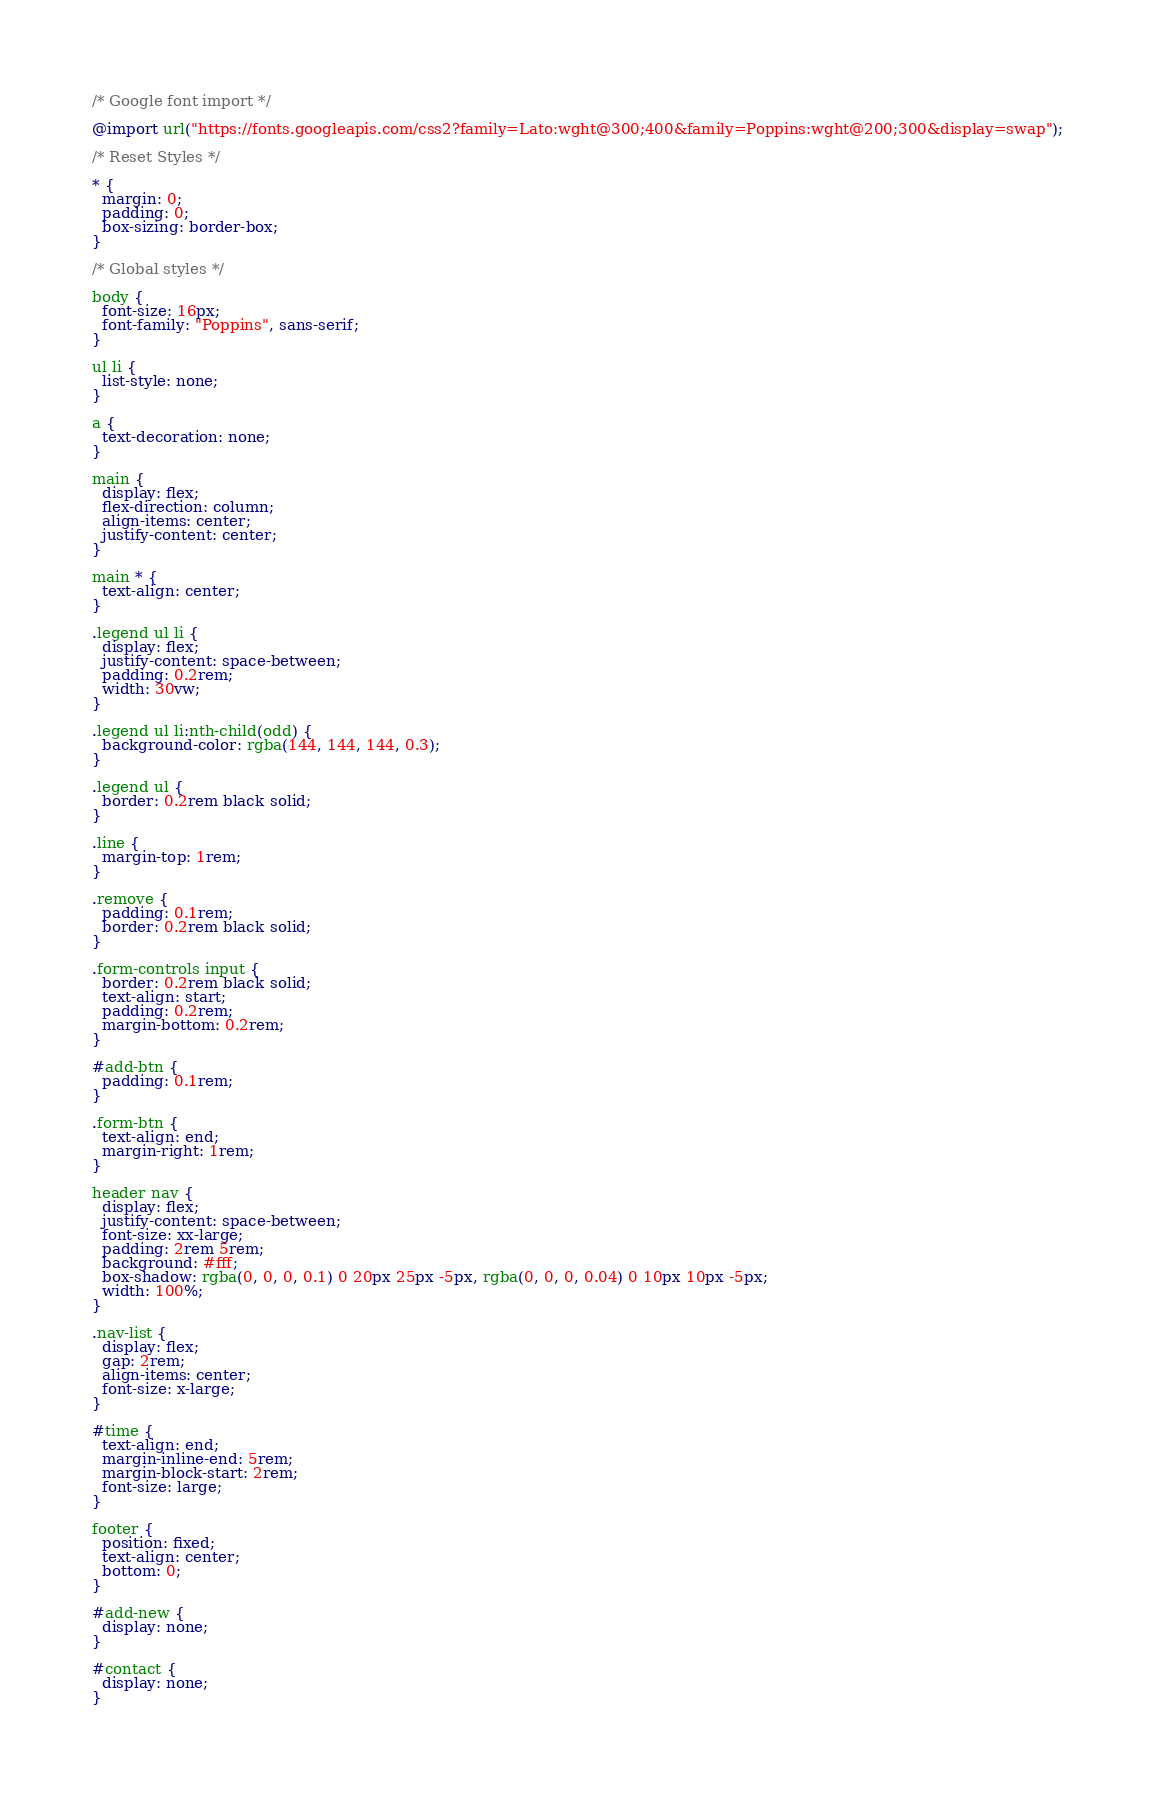<code> <loc_0><loc_0><loc_500><loc_500><_CSS_>/* Google font import */

@import url("https://fonts.googleapis.com/css2?family=Lato:wght@300;400&family=Poppins:wght@200;300&display=swap");

/* Reset Styles */

* {
  margin: 0;
  padding: 0;
  box-sizing: border-box;
}

/* Global styles */

body {
  font-size: 16px;
  font-family: "Poppins", sans-serif;
}

ul li {
  list-style: none;
}

a {
  text-decoration: none;
}

main {
  display: flex;
  flex-direction: column;
  align-items: center;
  justify-content: center;
}

main * {
  text-align: center;
}

.legend ul li {
  display: flex;
  justify-content: space-between;
  padding: 0.2rem;
  width: 30vw;
}

.legend ul li:nth-child(odd) {
  background-color: rgba(144, 144, 144, 0.3);
}

.legend ul {
  border: 0.2rem black solid;
}

.line {
  margin-top: 1rem;
}

.remove {
  padding: 0.1rem;
  border: 0.2rem black solid;
}

.form-controls input {
  border: 0.2rem black solid;
  text-align: start;
  padding: 0.2rem;
  margin-bottom: 0.2rem;
}

#add-btn {
  padding: 0.1rem;
}

.form-btn {
  text-align: end;
  margin-right: 1rem;
}

header nav {
  display: flex;
  justify-content: space-between;
  font-size: xx-large;
  padding: 2rem 5rem;
  background: #fff;
  box-shadow: rgba(0, 0, 0, 0.1) 0 20px 25px -5px, rgba(0, 0, 0, 0.04) 0 10px 10px -5px;
  width: 100%;
}

.nav-list {
  display: flex;
  gap: 2rem;
  align-items: center;
  font-size: x-large;
}

#time {
  text-align: end;
  margin-inline-end: 5rem;
  margin-block-start: 2rem;
  font-size: large;
}

footer {
  position: fixed;
  text-align: center;
  bottom: 0;
}

#add-new {
  display: none;
}

#contact {
  display: none;
}
</code> 